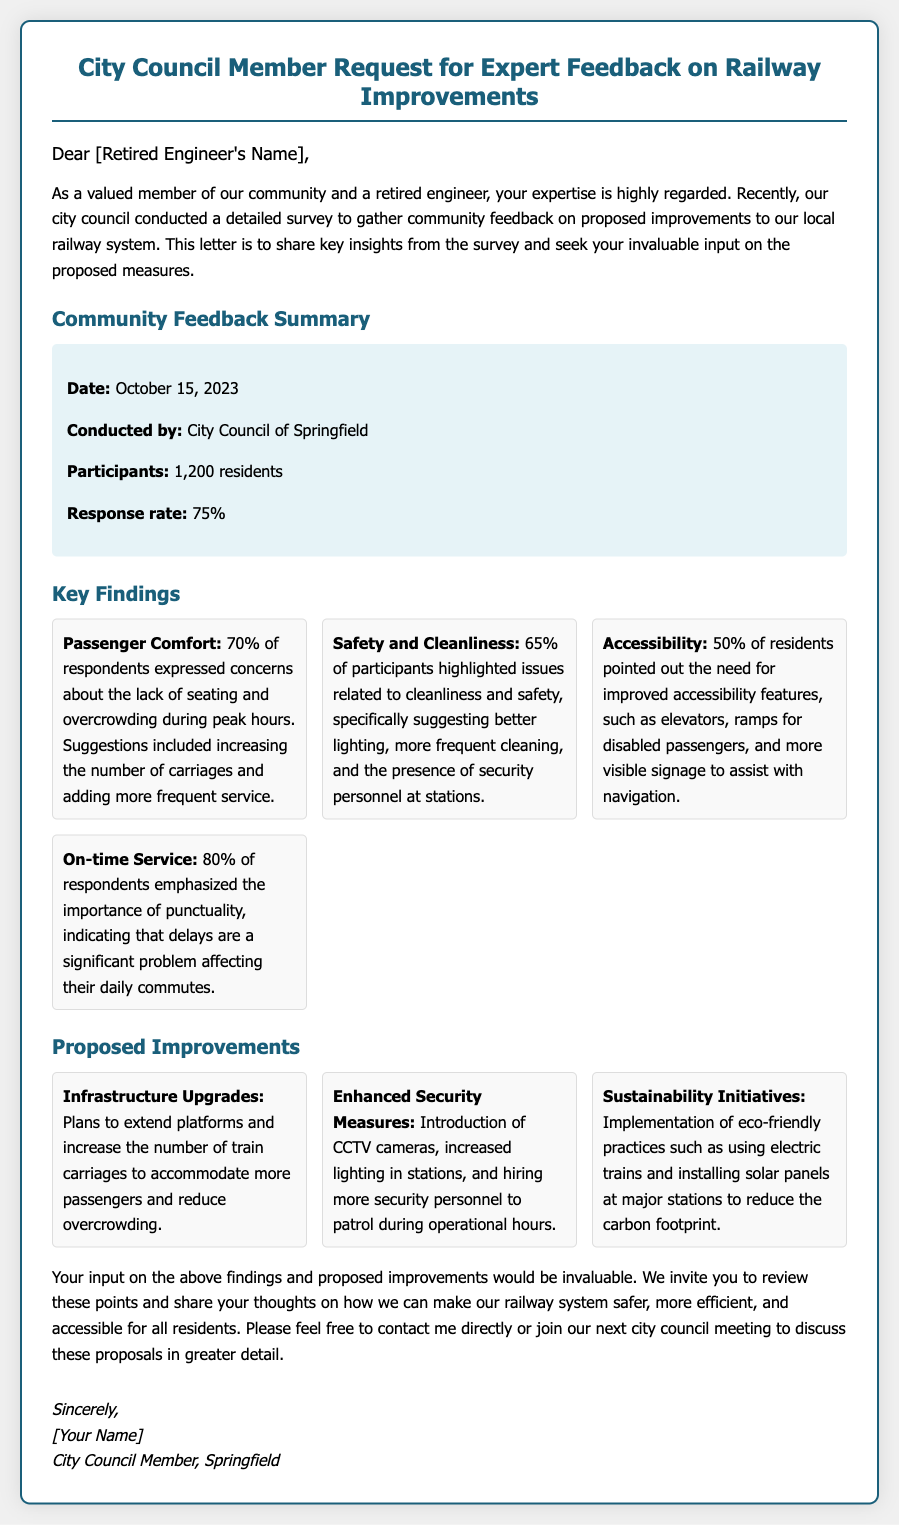What date was the survey conducted? The date of the survey is explicitly stated in the document as October 15, 2023.
Answer: October 15, 2023 Who conducted the survey? The document clearly states that the survey was conducted by the City Council of Springfield.
Answer: City Council of Springfield What was the response rate of the survey? The response rate is provided in the survey summary section, which states it is 75%.
Answer: 75% What percentage of respondents highlighted safety and cleanliness issues? This information is found in the key findings section, where it states that 65% expressed concerns on this matter.
Answer: 65% What is one proposed improvement related to security measures? The document mentions several improvements, one of which is the introduction of CCTV cameras.
Answer: CCTV cameras How many passengers expressed concerns about overcrowding? The key finding regarding passenger comfort states that 70% of respondents expressed concerns about overcrowding.
Answer: 70% What type of initiatives is mentioned under sustainability? The document refers to eco-friendly practices, including the use of electric trains as part of sustainability initiatives.
Answer: Electric trains What is the primary focus of the letter? The letter's primary focus is to seek expert feedback on railway improvements based on community feedback.
Answer: Expert feedback What is the closing of the letter signed off with? The signature section of the letter mentions the closing sign-off as "Sincerely."
Answer: Sincerely 